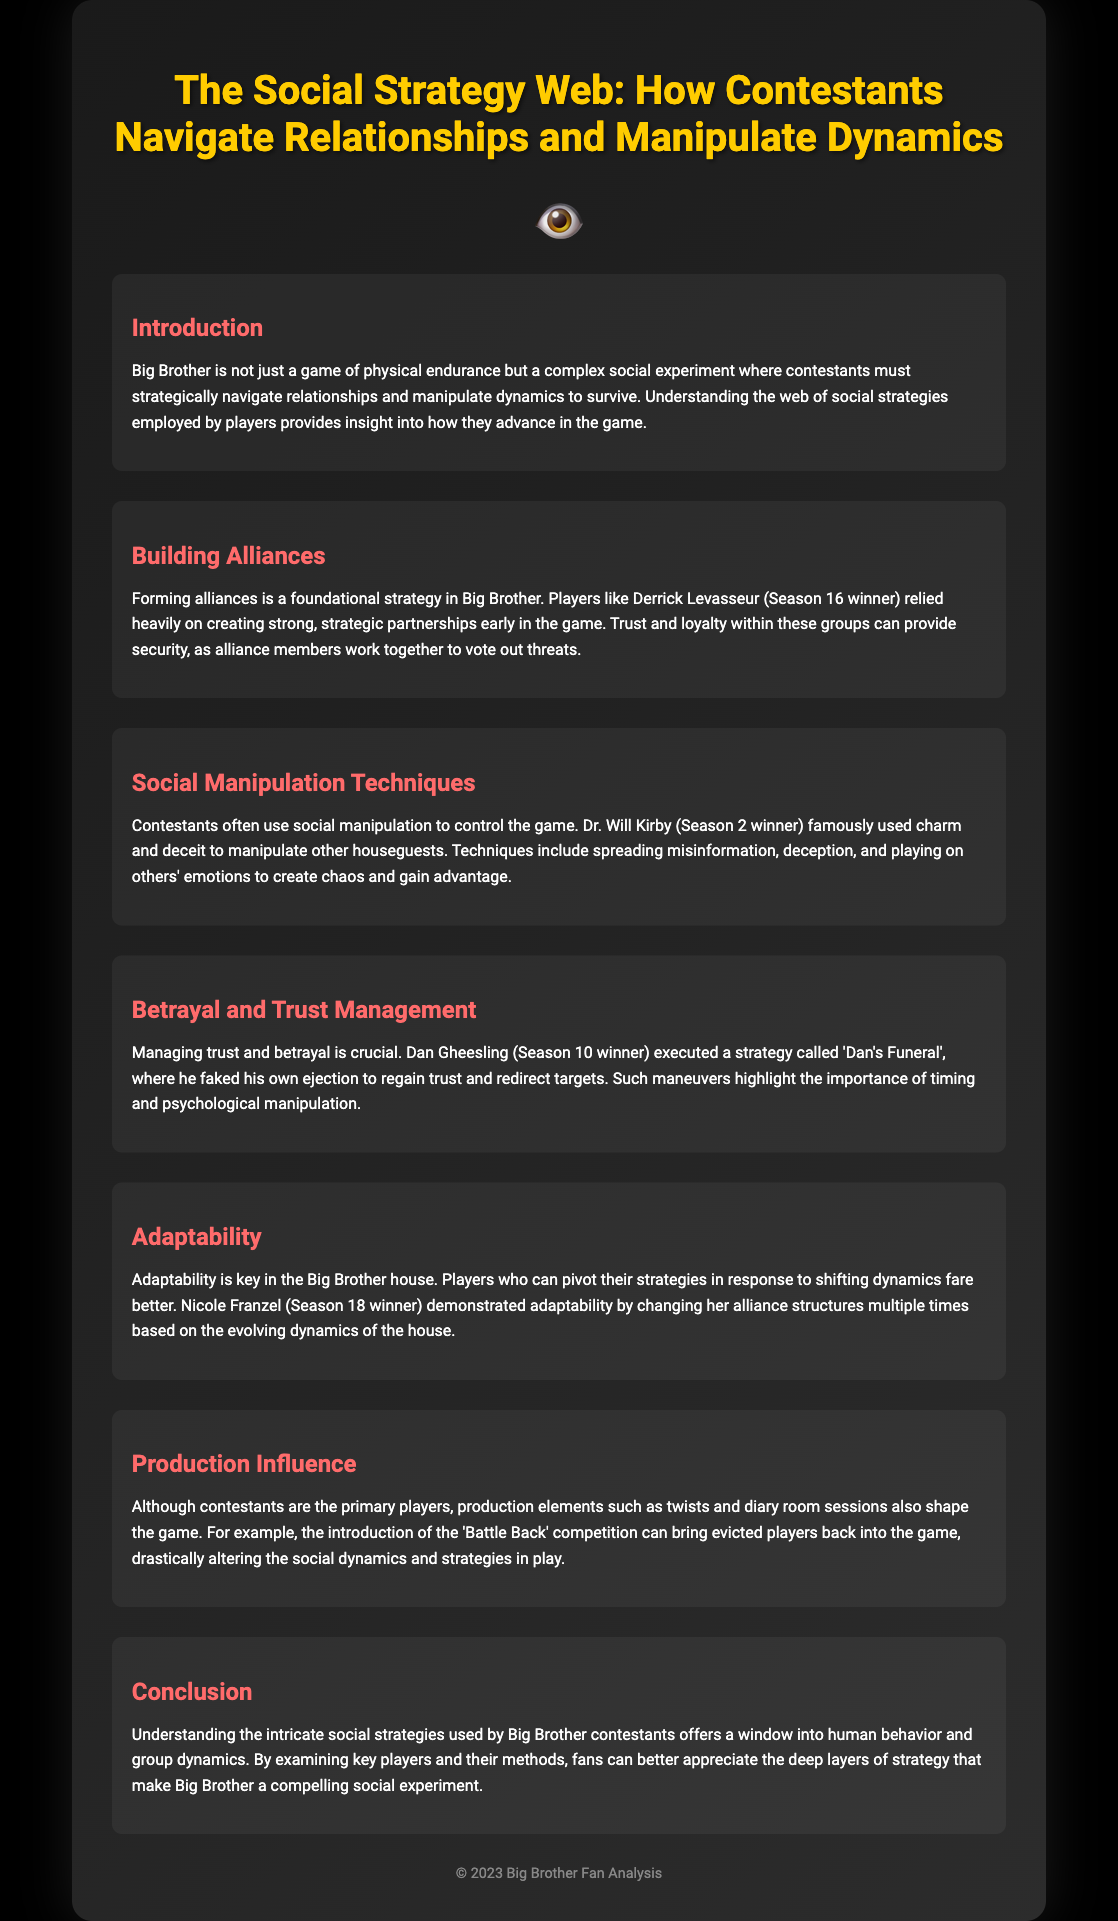What is the title of the poster? The title of the poster is provided in the header section.
Answer: The Social Strategy Web: How Contestants Navigate Relationships and Manipulate Dynamics Who is the season 16 winner mentioned? The document identifies a specific player who won Season 16 known for alliances.
Answer: Derrick Levasseur What is one social manipulation technique used by contestants? The document lists various techniques for social manipulation employed by contestants.
Answer: Misinformation What strategy did Dan Gheesling use to regain trust? The document describes a specific strategy used by a winner to manage trust and betrayal.
Answer: Dan's Funeral Which season winner demonstrated adaptability? The text refers to a season winner who showcased adaptability in changing alliances.
Answer: Nicole Franzel What production element can alter social dynamics? The document discusses how certain production elements can influence the perception and strategies in the game.
Answer: Battle Back What is a key concept introduced in the conclusion? The conclusion emphasizes a significant aspect of contestant strategies discussed earlier.
Answer: Social strategies What color is primarily used for the title? The title's color is mentioned in the styling section of the document.
Answer: Yellow 